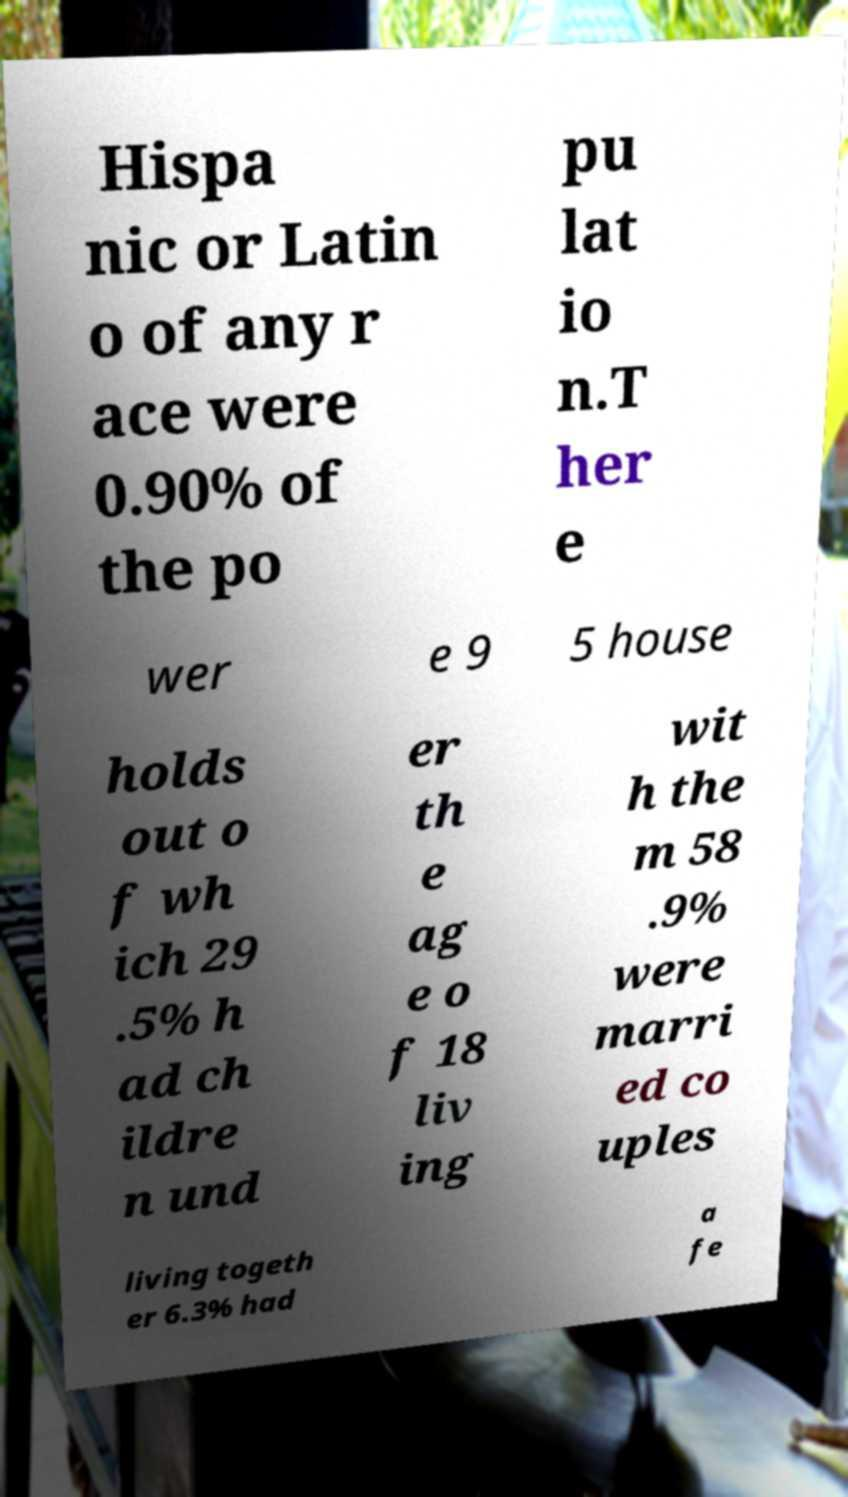Please read and relay the text visible in this image. What does it say? Hispa nic or Latin o of any r ace were 0.90% of the po pu lat io n.T her e wer e 9 5 house holds out o f wh ich 29 .5% h ad ch ildre n und er th e ag e o f 18 liv ing wit h the m 58 .9% were marri ed co uples living togeth er 6.3% had a fe 